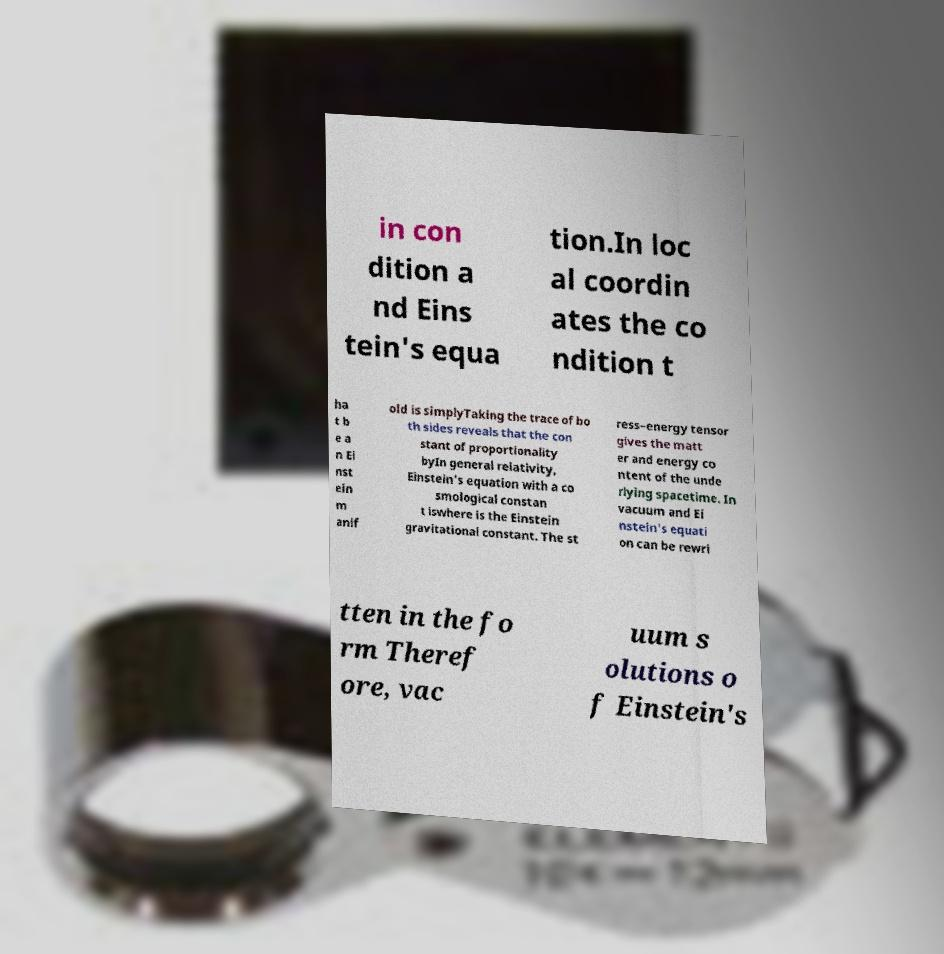Please read and relay the text visible in this image. What does it say? in con dition a nd Eins tein's equa tion.In loc al coordin ates the co ndition t ha t b e a n Ei nst ein m anif old is simplyTaking the trace of bo th sides reveals that the con stant of proportionality byIn general relativity, Einstein's equation with a co smological constan t iswhere is the Einstein gravitational constant. The st ress–energy tensor gives the matt er and energy co ntent of the unde rlying spacetime. In vacuum and Ei nstein's equati on can be rewri tten in the fo rm Theref ore, vac uum s olutions o f Einstein's 